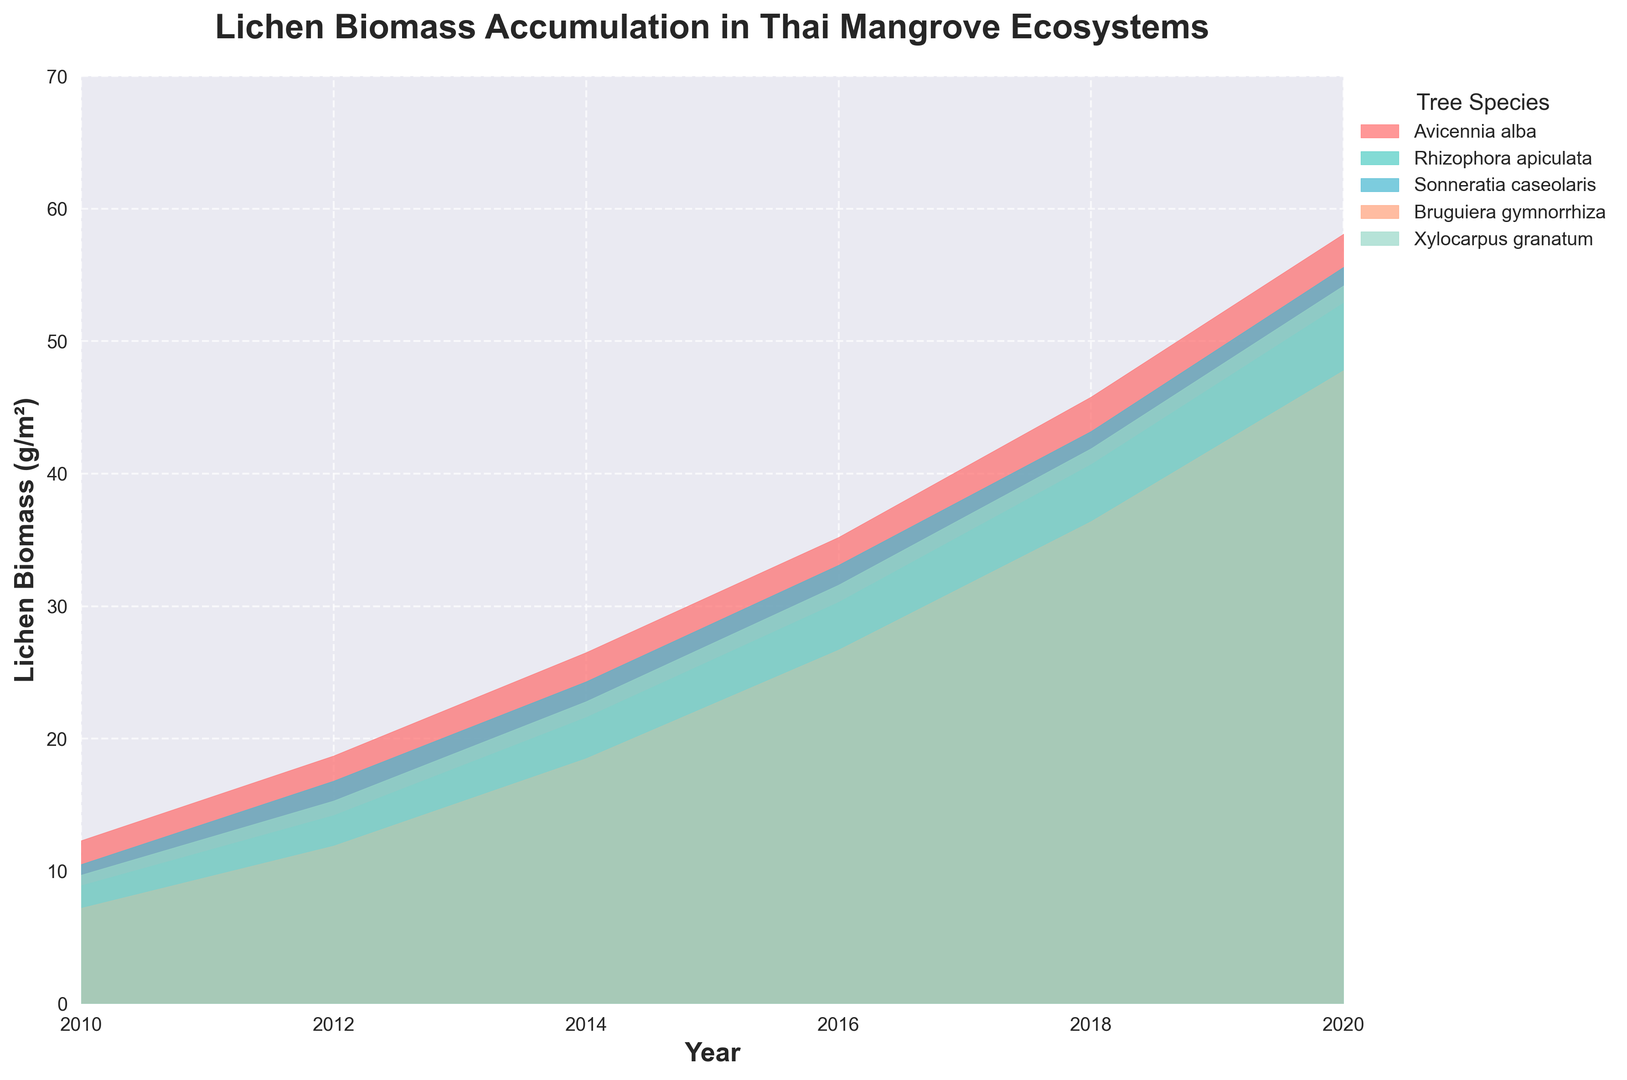Which tree species has the highest lichen biomass accumulation in 2020? Reviewing the chart, we can see the lichen biomass accumulation of each tree species in 2020. Avicennia alba has the highest value.
Answer: Avicennia alba Which tree species shows the steepest increase in lichen biomass from 2010 to 2020? By comparing the slopes of the lines for each species from 2010 to 2020, the steepest increase is seen for Avicennia alba.
Answer: Avicennia alba What is the total lichen biomass accumulation across all tree species in 2018? Add up the values for lichen biomass from each species in 2018: Avicennia alba (45.8) + Rhizophora apiculata (40.7) + Sonneratia caseolaris (43.2) + Bruguiera gymnorrhiza (36.4) + Xylocarpus granatum (41.9). The total is 45.8 + 40.7 + 43.2 + 36.4 + 41.9 = 208
Answer: 208 Which two species have the closest lichen biomass values in 2014? Looking at the chart, compare the 2014 data points for all species. Sonneratia caseolaris (24.3) and Xylocarpus granatum (22.8) have the closest values.
Answer: Sonneratia caseolaris and Xylocarpus granatum During which year did Bruguiera gymnorrhiza surpass 20 g/m2 of lichen biomass? Observe the trend for Bruguiera gymnorrhiza. It surpassed 20 g/m2 between 2012 (11.9) and 2014 (18.5). So, it surpassed this threshold in 2016 when it reached 26.7 g/m2.
Answer: 2016 Rank the tree species in descending order of their lichen biomass in 2016. Fetch the data for 2016: Avicennia alba (35.2), Rhizophora apiculata (30.3), Sonneratia caseolaris (33.1), Bruguiera gymnorrhiza (26.7), Xylocarpus granatum (31.6). The descending order would be: Avicennia alba > Sonneratia caseolaris > Xylocarpus granatum > Rhizophora apiculata > Bruguiera gymnorrhiza.
Answer: Avicennia alba, Sonneratia caseolaris, Xylocarpus granatum, Rhizophora apiculata, Bruguiera gymnorrhiza Which tree species shows the slowest lichen biomass accumulation rate? Examine the overall trend lines; Bruguiera gymnorrhiza consistently has the lower biomass values each year compared to other species.
Answer: Bruguiera gymnorrhiza What is the percentage increase in lichen biomass for Avicennia alba from 2010 to 2020? The biomass in 2010 is 12.3 and in 2020 is 58.1 for Avicennia alba. The percentage increase is calculated as ((58.1 - 12.3) / 12.3) * 100 = 372.4%
Answer: 372.4% Which tree species has a lichen biomass value closest to 40 g/m2 in 2018? Identify the species biomass values in 2018, the closest value to 40 g/m2 is for Rhizophora apiculata with 40.7.
Answer: Rhizophora apiculata 